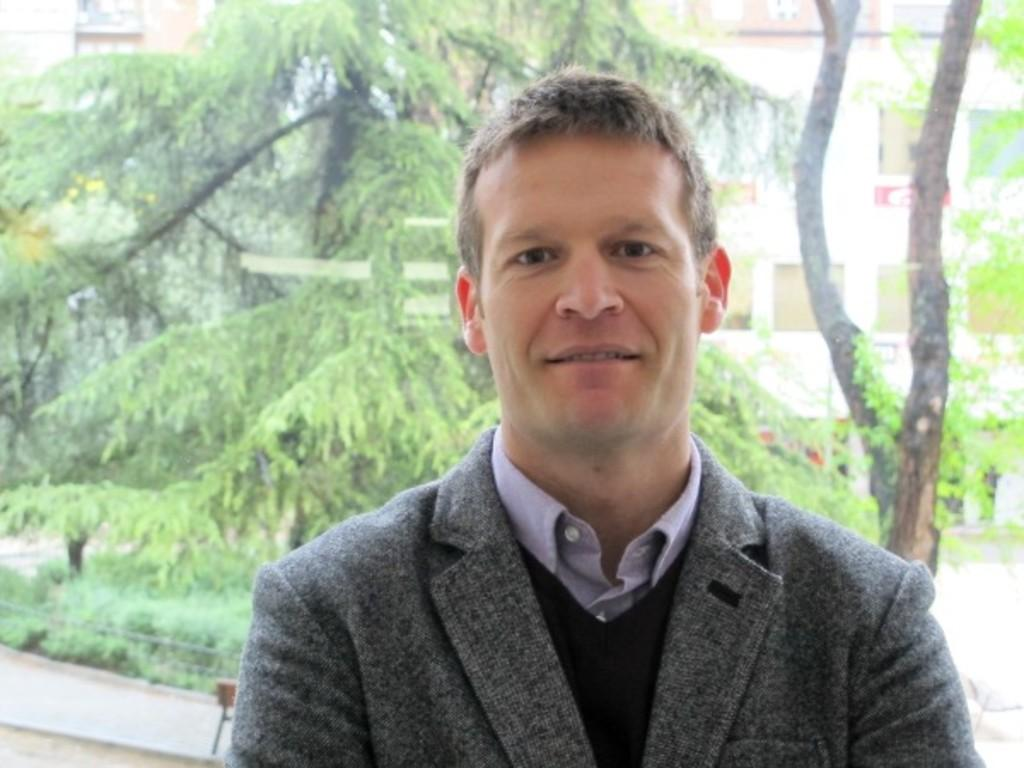Who is present in the image? There is a man in the image. What is the man wearing? The man is wearing an ash-colored jacket. What can be seen in the background of the image on the left side? There are trees in the background of the image on the left side. What can be seen in the background of the image on the right side? There is a building in the background of the image on the right side. Can you see any snails crawling on the ash-colored jacket in the image? There are no snails visible on the man's jacket in the image. How much sugar is present in the trees on the left side of the image? There is no sugar mentioned or visible in the trees in the image. 